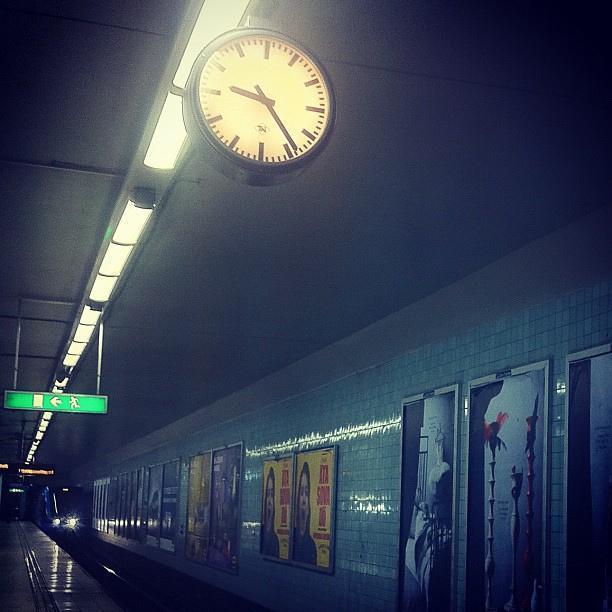How many trains are in the photo?
Give a very brief answer. 2. 